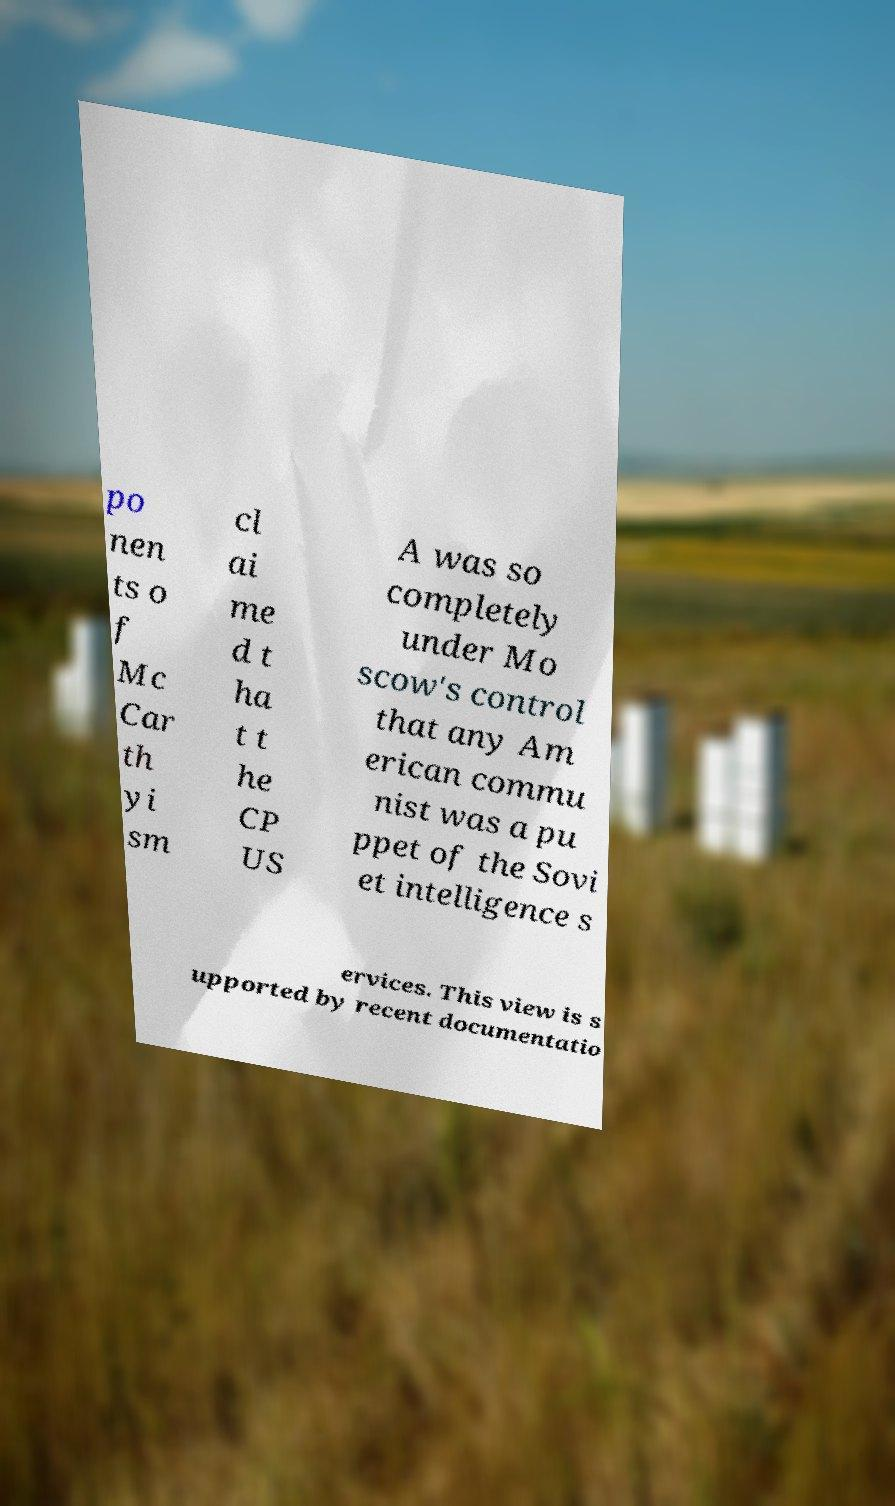Please read and relay the text visible in this image. What does it say? po nen ts o f Mc Car th yi sm cl ai me d t ha t t he CP US A was so completely under Mo scow's control that any Am erican commu nist was a pu ppet of the Sovi et intelligence s ervices. This view is s upported by recent documentatio 